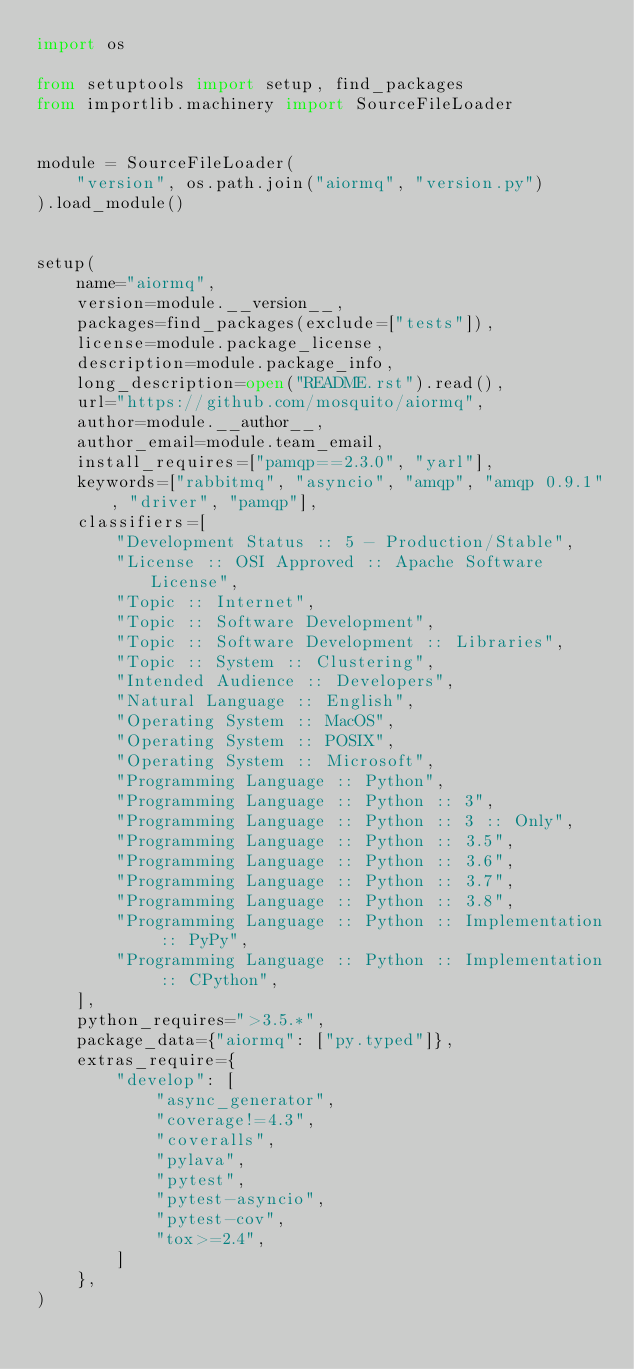Convert code to text. <code><loc_0><loc_0><loc_500><loc_500><_Python_>import os

from setuptools import setup, find_packages
from importlib.machinery import SourceFileLoader


module = SourceFileLoader(
    "version", os.path.join("aiormq", "version.py")
).load_module()


setup(
    name="aiormq",
    version=module.__version__,
    packages=find_packages(exclude=["tests"]),
    license=module.package_license,
    description=module.package_info,
    long_description=open("README.rst").read(),
    url="https://github.com/mosquito/aiormq",
    author=module.__author__,
    author_email=module.team_email,
    install_requires=["pamqp==2.3.0", "yarl"],
    keywords=["rabbitmq", "asyncio", "amqp", "amqp 0.9.1", "driver", "pamqp"],
    classifiers=[
        "Development Status :: 5 - Production/Stable",
        "License :: OSI Approved :: Apache Software License",
        "Topic :: Internet",
        "Topic :: Software Development",
        "Topic :: Software Development :: Libraries",
        "Topic :: System :: Clustering",
        "Intended Audience :: Developers",
        "Natural Language :: English",
        "Operating System :: MacOS",
        "Operating System :: POSIX",
        "Operating System :: Microsoft",
        "Programming Language :: Python",
        "Programming Language :: Python :: 3",
        "Programming Language :: Python :: 3 :: Only",
        "Programming Language :: Python :: 3.5",
        "Programming Language :: Python :: 3.6",
        "Programming Language :: Python :: 3.7",
        "Programming Language :: Python :: 3.8",
        "Programming Language :: Python :: Implementation :: PyPy",
        "Programming Language :: Python :: Implementation :: CPython",
    ],
    python_requires=">3.5.*",
    package_data={"aiormq": ["py.typed"]},
    extras_require={
        "develop": [
            "async_generator",
            "coverage!=4.3",
            "coveralls",
            "pylava",
            "pytest",
            "pytest-asyncio",
            "pytest-cov",
            "tox>=2.4",
        ]
    },
)
</code> 